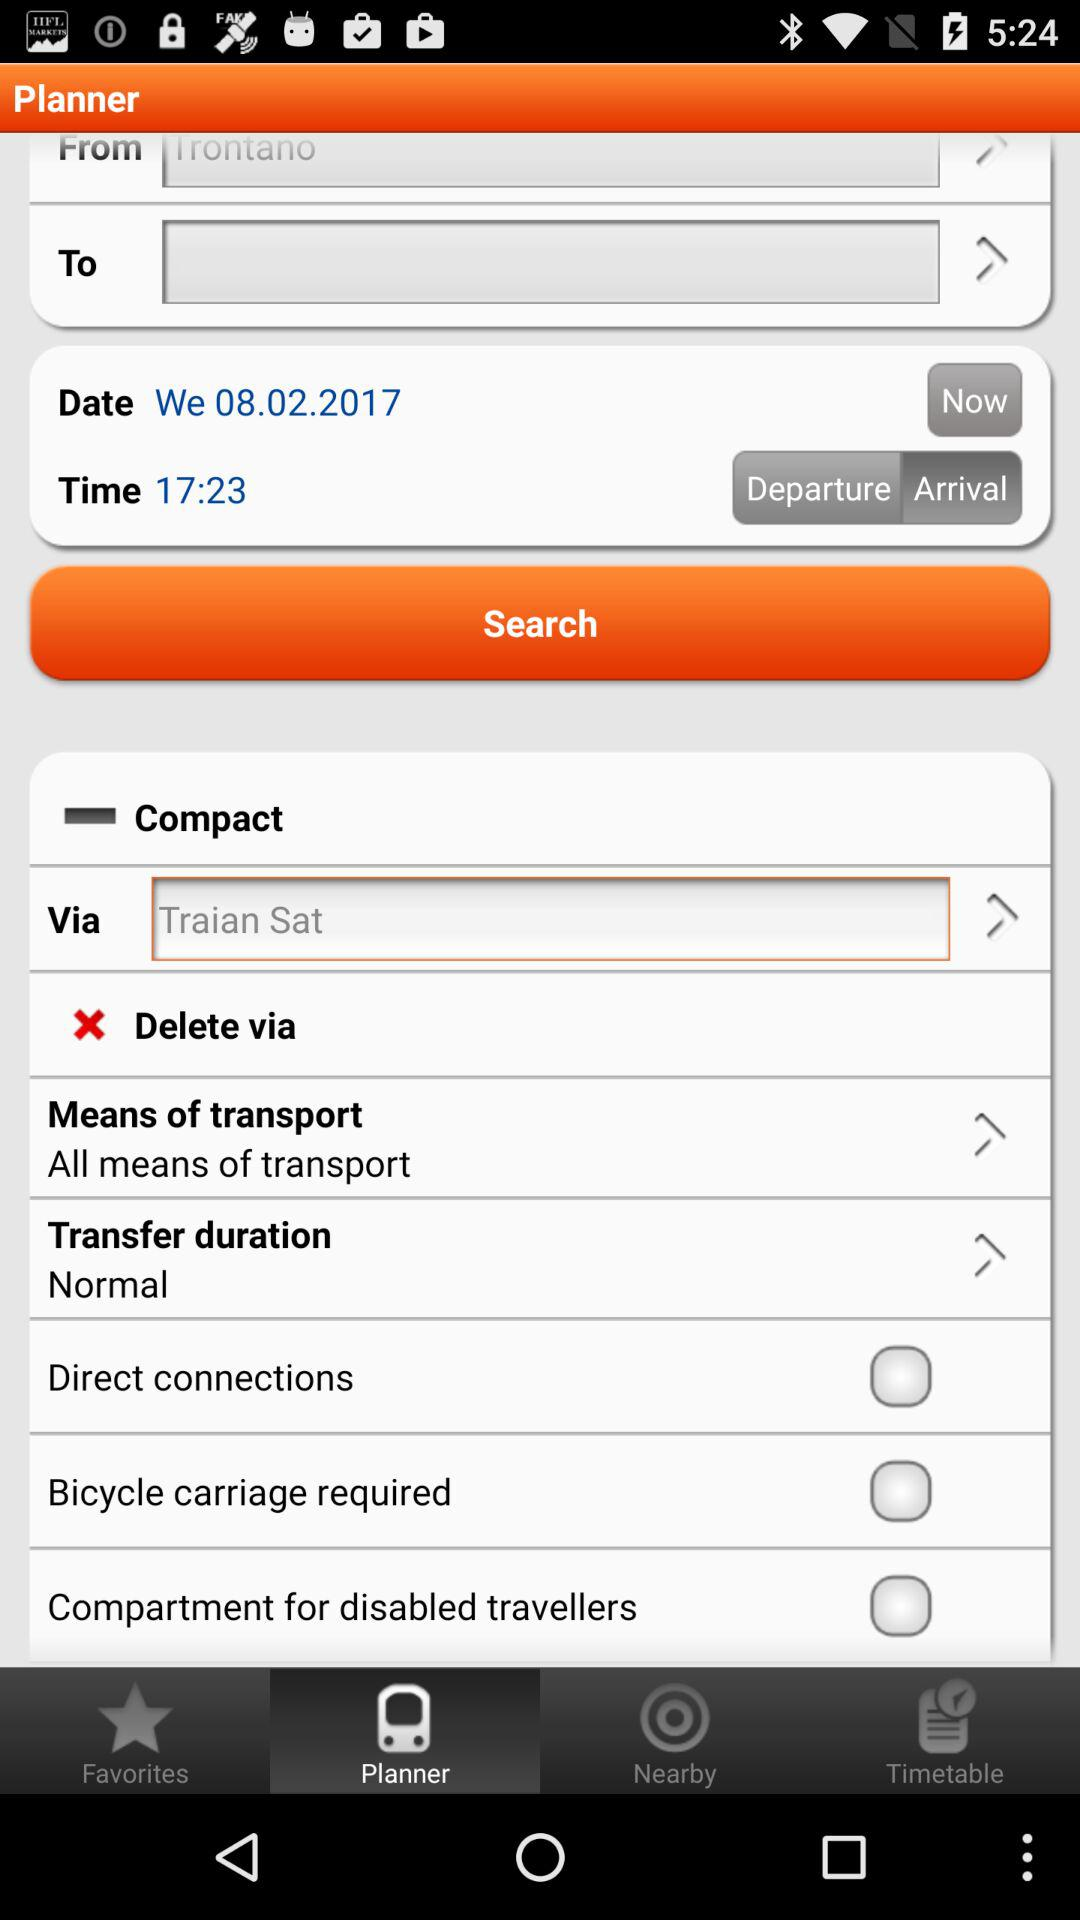What is the date given? The given date is 08.02.2017. 